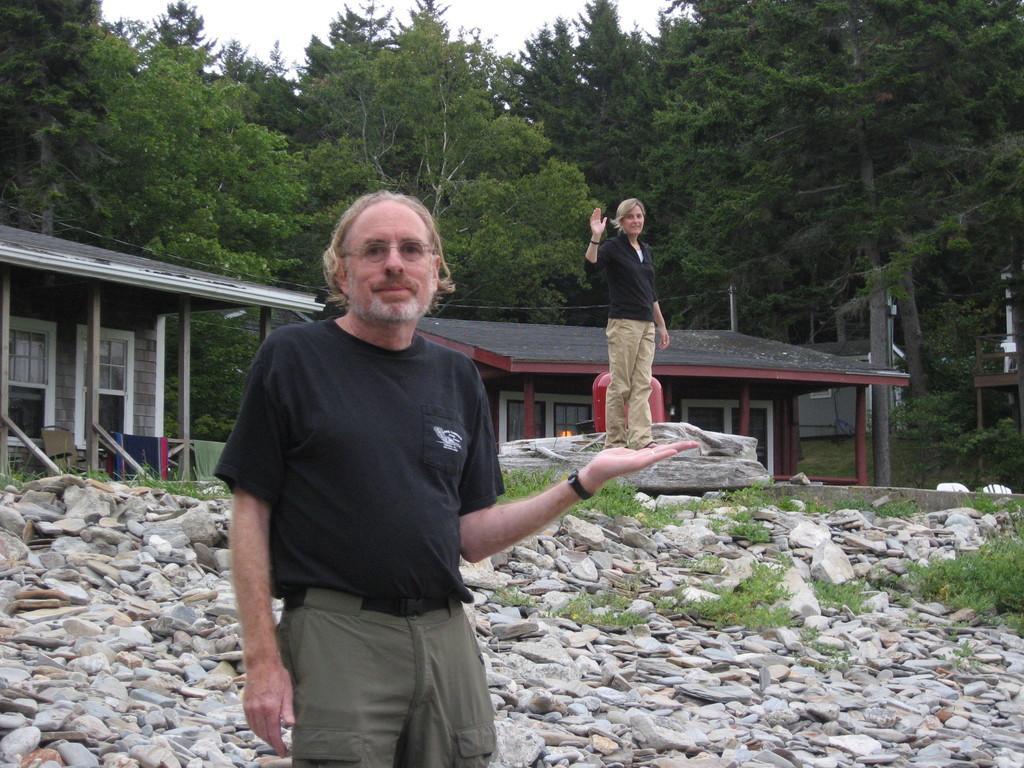In one or two sentences, can you explain what this image depicts? This image consists of two persons. In the front, there is a man wearing a black T-shirt. In the background, there is a woman standing on the rock. At the bottom, there are stones and rocks. In the background, there are two houses along with the trees. At the top, there is a sky. 